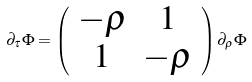<formula> <loc_0><loc_0><loc_500><loc_500>\partial _ { \tau } \Phi = \left ( \begin{array} { c c } - \rho & 1 \\ 1 & - \rho \end{array} \right ) \partial _ { \rho } \Phi</formula> 